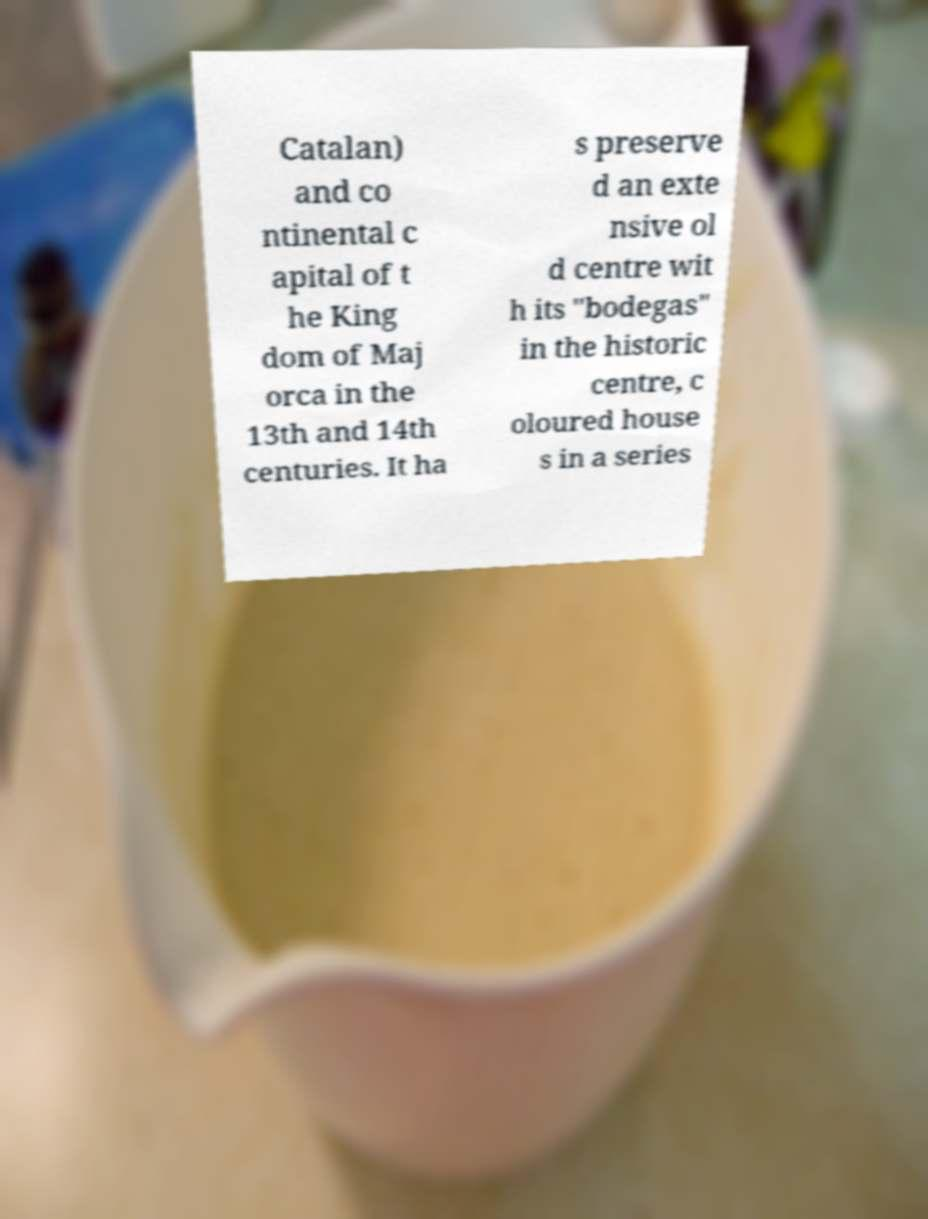Could you assist in decoding the text presented in this image and type it out clearly? Catalan) and co ntinental c apital of t he King dom of Maj orca in the 13th and 14th centuries. It ha s preserve d an exte nsive ol d centre wit h its "bodegas" in the historic centre, c oloured house s in a series 